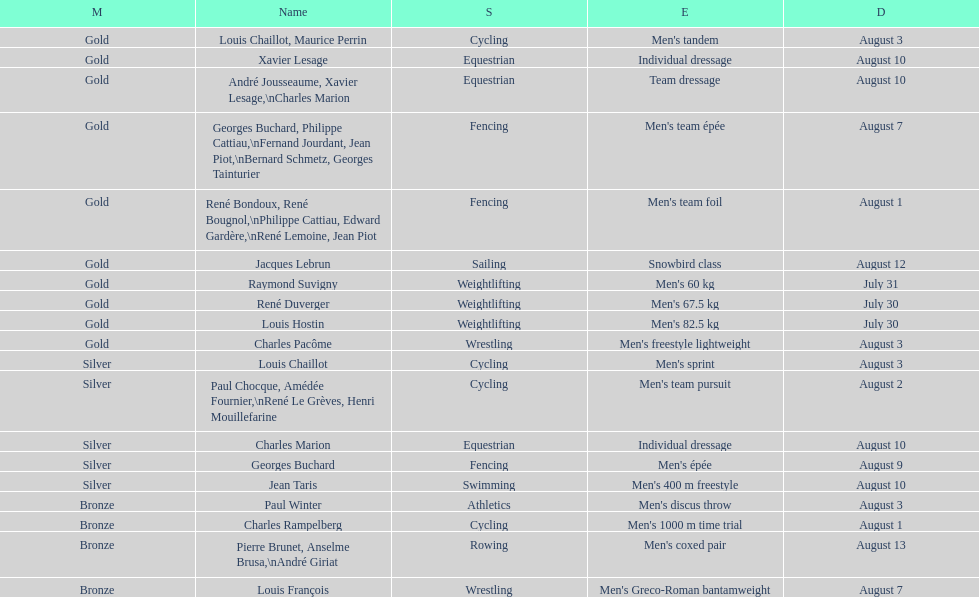Was the number of gold medals higher than silver? Yes. Write the full table. {'header': ['M', 'Name', 'S', 'E', 'D'], 'rows': [['Gold', 'Louis Chaillot, Maurice Perrin', 'Cycling', "Men's tandem", 'August 3'], ['Gold', 'Xavier Lesage', 'Equestrian', 'Individual dressage', 'August 10'], ['Gold', 'André Jousseaume, Xavier Lesage,\\nCharles Marion', 'Equestrian', 'Team dressage', 'August 10'], ['Gold', 'Georges Buchard, Philippe Cattiau,\\nFernand Jourdant, Jean Piot,\\nBernard Schmetz, Georges Tainturier', 'Fencing', "Men's team épée", 'August 7'], ['Gold', 'René Bondoux, René Bougnol,\\nPhilippe Cattiau, Edward Gardère,\\nRené Lemoine, Jean Piot', 'Fencing', "Men's team foil", 'August 1'], ['Gold', 'Jacques Lebrun', 'Sailing', 'Snowbird class', 'August 12'], ['Gold', 'Raymond Suvigny', 'Weightlifting', "Men's 60 kg", 'July 31'], ['Gold', 'René Duverger', 'Weightlifting', "Men's 67.5 kg", 'July 30'], ['Gold', 'Louis Hostin', 'Weightlifting', "Men's 82.5 kg", 'July 30'], ['Gold', 'Charles Pacôme', 'Wrestling', "Men's freestyle lightweight", 'August 3'], ['Silver', 'Louis Chaillot', 'Cycling', "Men's sprint", 'August 3'], ['Silver', 'Paul Chocque, Amédée Fournier,\\nRené Le Grèves, Henri Mouillefarine', 'Cycling', "Men's team pursuit", 'August 2'], ['Silver', 'Charles Marion', 'Equestrian', 'Individual dressage', 'August 10'], ['Silver', 'Georges Buchard', 'Fencing', "Men's épée", 'August 9'], ['Silver', 'Jean Taris', 'Swimming', "Men's 400 m freestyle", 'August 10'], ['Bronze', 'Paul Winter', 'Athletics', "Men's discus throw", 'August 3'], ['Bronze', 'Charles Rampelberg', 'Cycling', "Men's 1000 m time trial", 'August 1'], ['Bronze', 'Pierre Brunet, Anselme Brusa,\\nAndré Giriat', 'Rowing', "Men's coxed pair", 'August 13'], ['Bronze', 'Louis François', 'Wrestling', "Men's Greco-Roman bantamweight", 'August 7']]} 